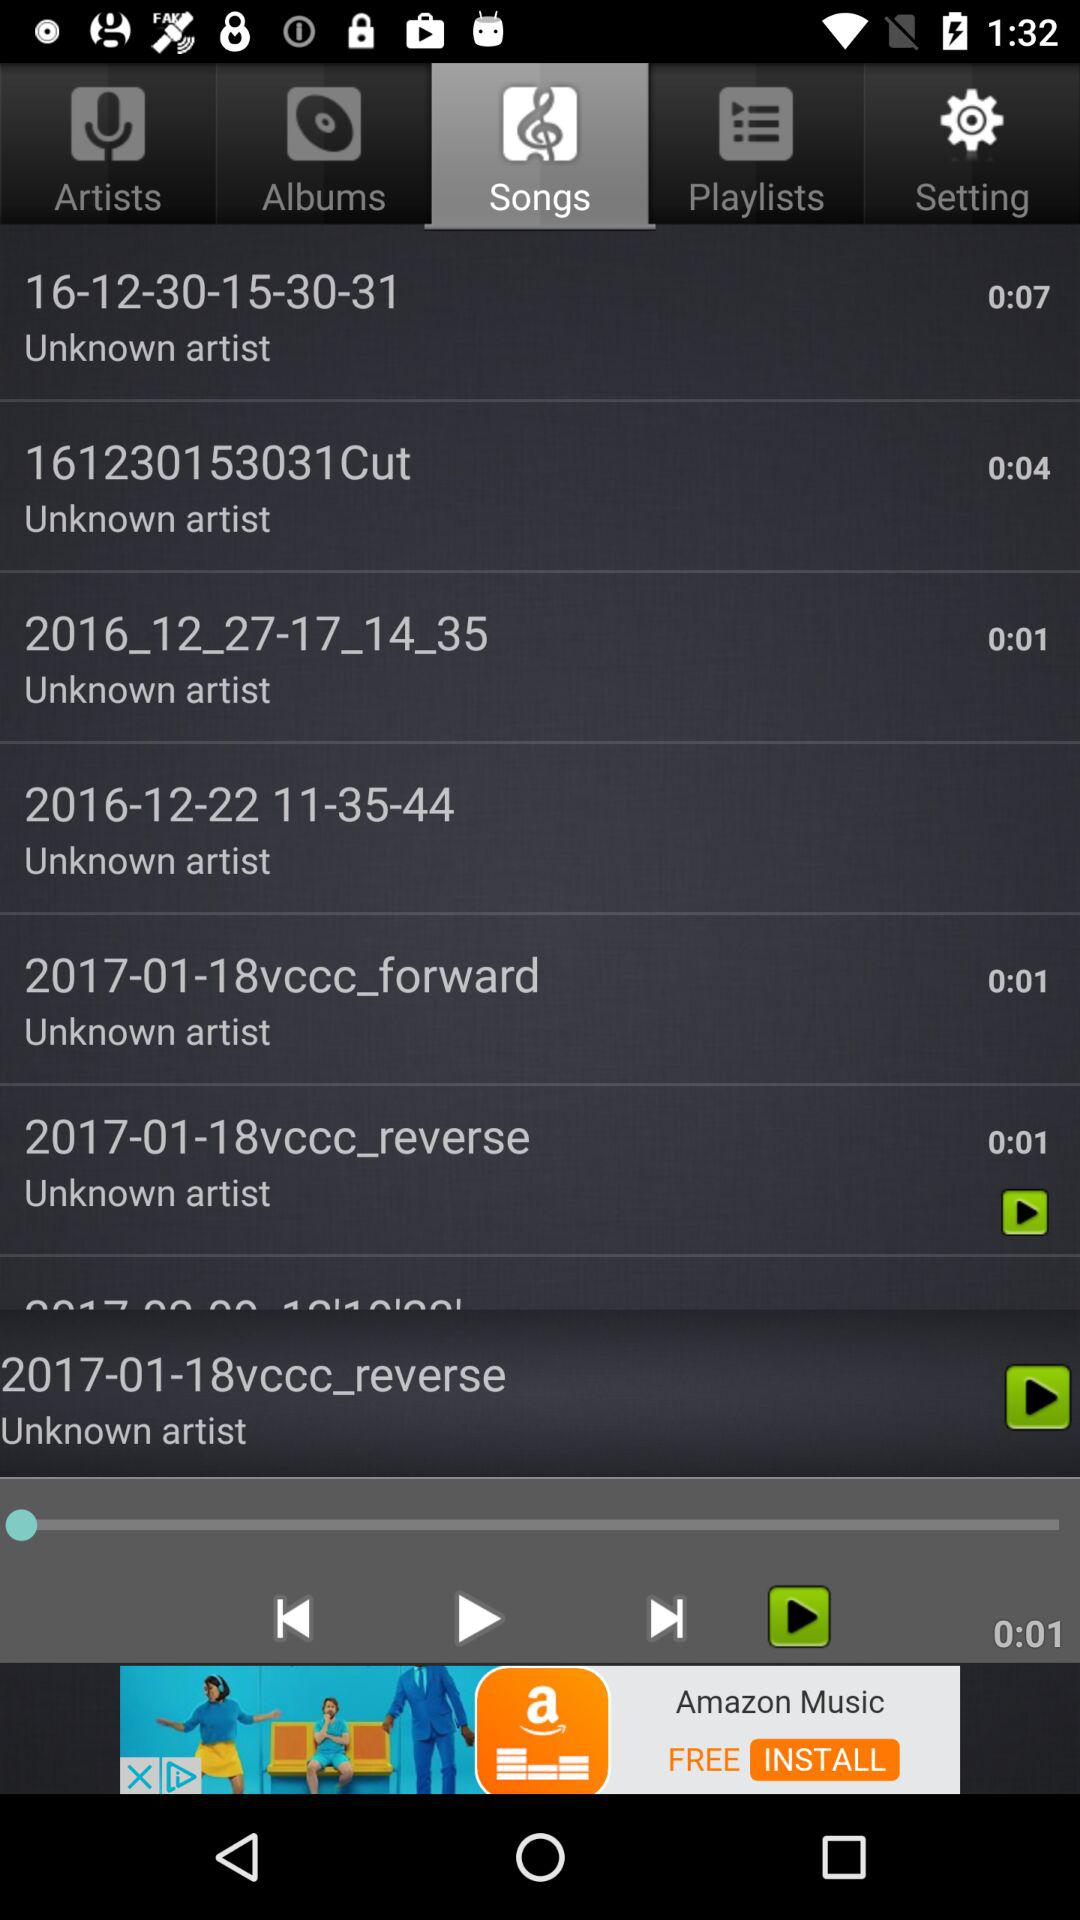Which tab am I on? You are on "Songs" tab. 